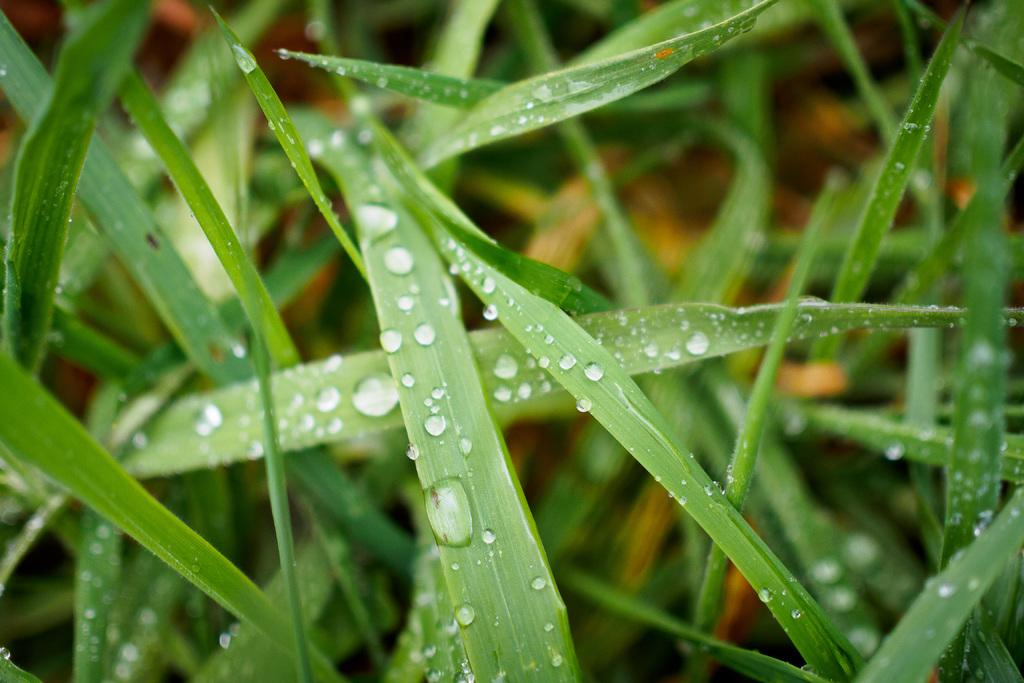What can be seen on the leafs in the image? There are water droplets on the leafs in the image. How would you describe the background of the image? The background of the image is blurred. Reasoning: Let's think step by identifying the main subjects and objects in the image based on the provided facts. We then formulate questions that focus on the location and characteristics of these subjects and objects, ensuring that each question can be answered definitively with the information given. We avoid yes/no questions and ensure that the language is simple and clear. Absurd Question/Answer: How many pies are visible in the image? There are no pies present in the image. What type of line can be seen in the image? There is no line present in the image. What is the amount of water droplets on the leafs in the image? There is no specific amount of water droplets mentioned in the facts, so it cannot be determined from the image. 